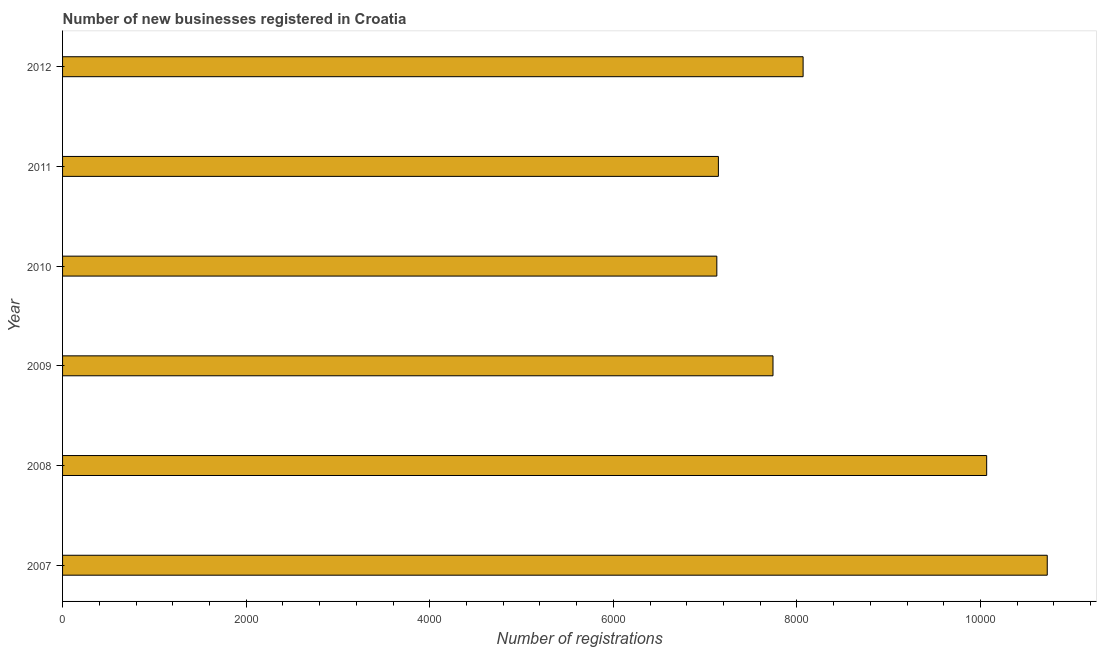Does the graph contain any zero values?
Offer a terse response. No. Does the graph contain grids?
Offer a very short reply. No. What is the title of the graph?
Provide a short and direct response. Number of new businesses registered in Croatia. What is the label or title of the X-axis?
Give a very brief answer. Number of registrations. What is the label or title of the Y-axis?
Your answer should be very brief. Year. What is the number of new business registrations in 2008?
Offer a terse response. 1.01e+04. Across all years, what is the maximum number of new business registrations?
Your answer should be compact. 1.07e+04. Across all years, what is the minimum number of new business registrations?
Your answer should be very brief. 7128. In which year was the number of new business registrations minimum?
Provide a succinct answer. 2010. What is the sum of the number of new business registrations?
Offer a terse response. 5.09e+04. What is the difference between the number of new business registrations in 2008 and 2010?
Provide a succinct answer. 2940. What is the average number of new business registrations per year?
Keep it short and to the point. 8479. What is the median number of new business registrations?
Ensure brevity in your answer.  7904. Do a majority of the years between 2010 and 2007 (inclusive) have number of new business registrations greater than 800 ?
Offer a terse response. Yes. What is the ratio of the number of new business registrations in 2009 to that in 2010?
Your answer should be compact. 1.09. What is the difference between the highest and the second highest number of new business registrations?
Offer a terse response. 660. Is the sum of the number of new business registrations in 2009 and 2012 greater than the maximum number of new business registrations across all years?
Provide a short and direct response. Yes. What is the difference between the highest and the lowest number of new business registrations?
Keep it short and to the point. 3600. In how many years, is the number of new business registrations greater than the average number of new business registrations taken over all years?
Provide a short and direct response. 2. Are all the bars in the graph horizontal?
Your answer should be very brief. Yes. How many years are there in the graph?
Make the answer very short. 6. Are the values on the major ticks of X-axis written in scientific E-notation?
Keep it short and to the point. No. What is the Number of registrations of 2007?
Your answer should be very brief. 1.07e+04. What is the Number of registrations of 2008?
Give a very brief answer. 1.01e+04. What is the Number of registrations in 2009?
Keep it short and to the point. 7740. What is the Number of registrations of 2010?
Your response must be concise. 7128. What is the Number of registrations of 2011?
Make the answer very short. 7145. What is the Number of registrations of 2012?
Your response must be concise. 8068. What is the difference between the Number of registrations in 2007 and 2008?
Your response must be concise. 660. What is the difference between the Number of registrations in 2007 and 2009?
Provide a succinct answer. 2988. What is the difference between the Number of registrations in 2007 and 2010?
Your answer should be compact. 3600. What is the difference between the Number of registrations in 2007 and 2011?
Provide a short and direct response. 3583. What is the difference between the Number of registrations in 2007 and 2012?
Your response must be concise. 2660. What is the difference between the Number of registrations in 2008 and 2009?
Provide a succinct answer. 2328. What is the difference between the Number of registrations in 2008 and 2010?
Provide a succinct answer. 2940. What is the difference between the Number of registrations in 2008 and 2011?
Ensure brevity in your answer.  2923. What is the difference between the Number of registrations in 2009 and 2010?
Give a very brief answer. 612. What is the difference between the Number of registrations in 2009 and 2011?
Keep it short and to the point. 595. What is the difference between the Number of registrations in 2009 and 2012?
Your response must be concise. -328. What is the difference between the Number of registrations in 2010 and 2012?
Make the answer very short. -940. What is the difference between the Number of registrations in 2011 and 2012?
Offer a terse response. -923. What is the ratio of the Number of registrations in 2007 to that in 2008?
Your answer should be very brief. 1.07. What is the ratio of the Number of registrations in 2007 to that in 2009?
Make the answer very short. 1.39. What is the ratio of the Number of registrations in 2007 to that in 2010?
Your answer should be compact. 1.5. What is the ratio of the Number of registrations in 2007 to that in 2011?
Ensure brevity in your answer.  1.5. What is the ratio of the Number of registrations in 2007 to that in 2012?
Offer a terse response. 1.33. What is the ratio of the Number of registrations in 2008 to that in 2009?
Offer a very short reply. 1.3. What is the ratio of the Number of registrations in 2008 to that in 2010?
Provide a short and direct response. 1.41. What is the ratio of the Number of registrations in 2008 to that in 2011?
Offer a terse response. 1.41. What is the ratio of the Number of registrations in 2008 to that in 2012?
Give a very brief answer. 1.25. What is the ratio of the Number of registrations in 2009 to that in 2010?
Your answer should be very brief. 1.09. What is the ratio of the Number of registrations in 2009 to that in 2011?
Your response must be concise. 1.08. What is the ratio of the Number of registrations in 2009 to that in 2012?
Your answer should be compact. 0.96. What is the ratio of the Number of registrations in 2010 to that in 2012?
Provide a succinct answer. 0.88. What is the ratio of the Number of registrations in 2011 to that in 2012?
Your response must be concise. 0.89. 